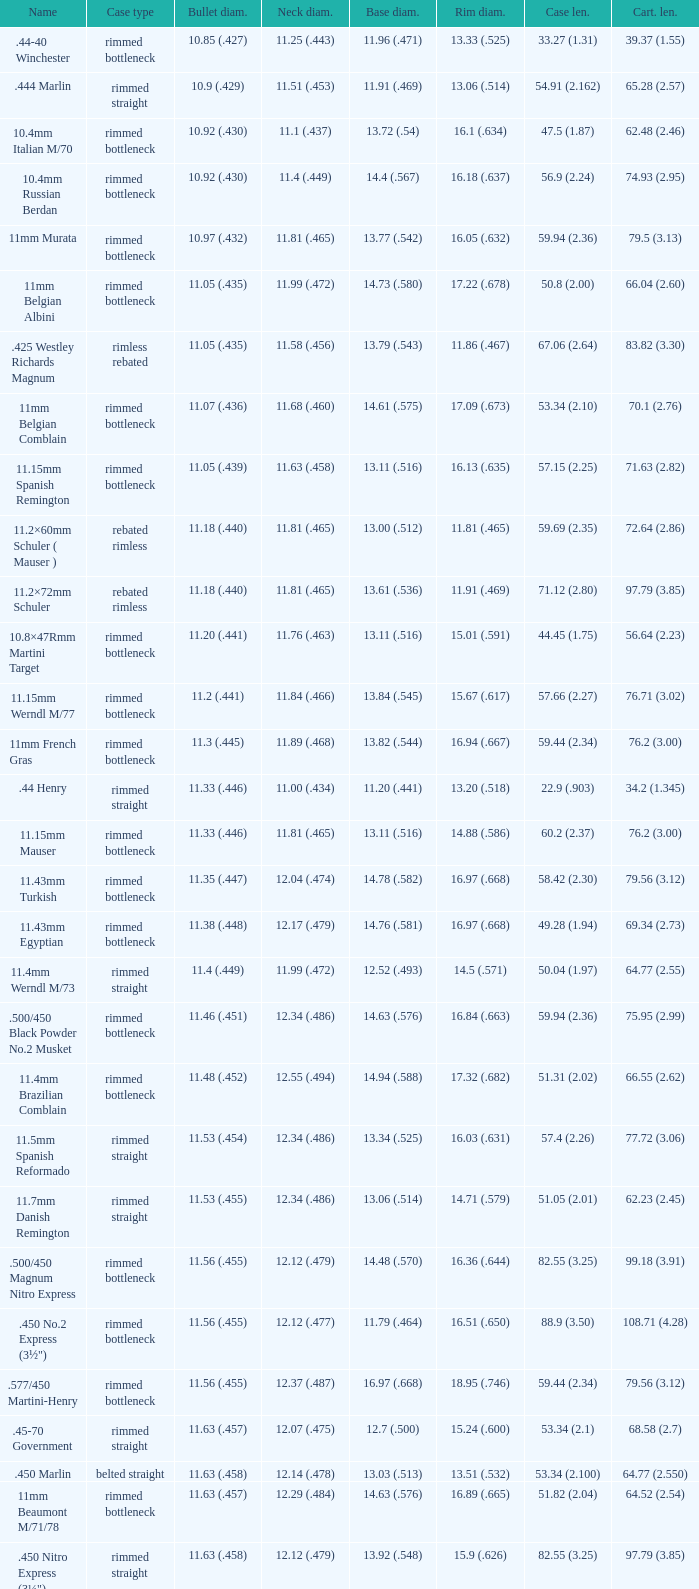Which Bullet diameter has a Neck diameter of 12.17 (.479)? 11.38 (.448). 